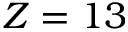<formula> <loc_0><loc_0><loc_500><loc_500>Z = 1 3</formula> 